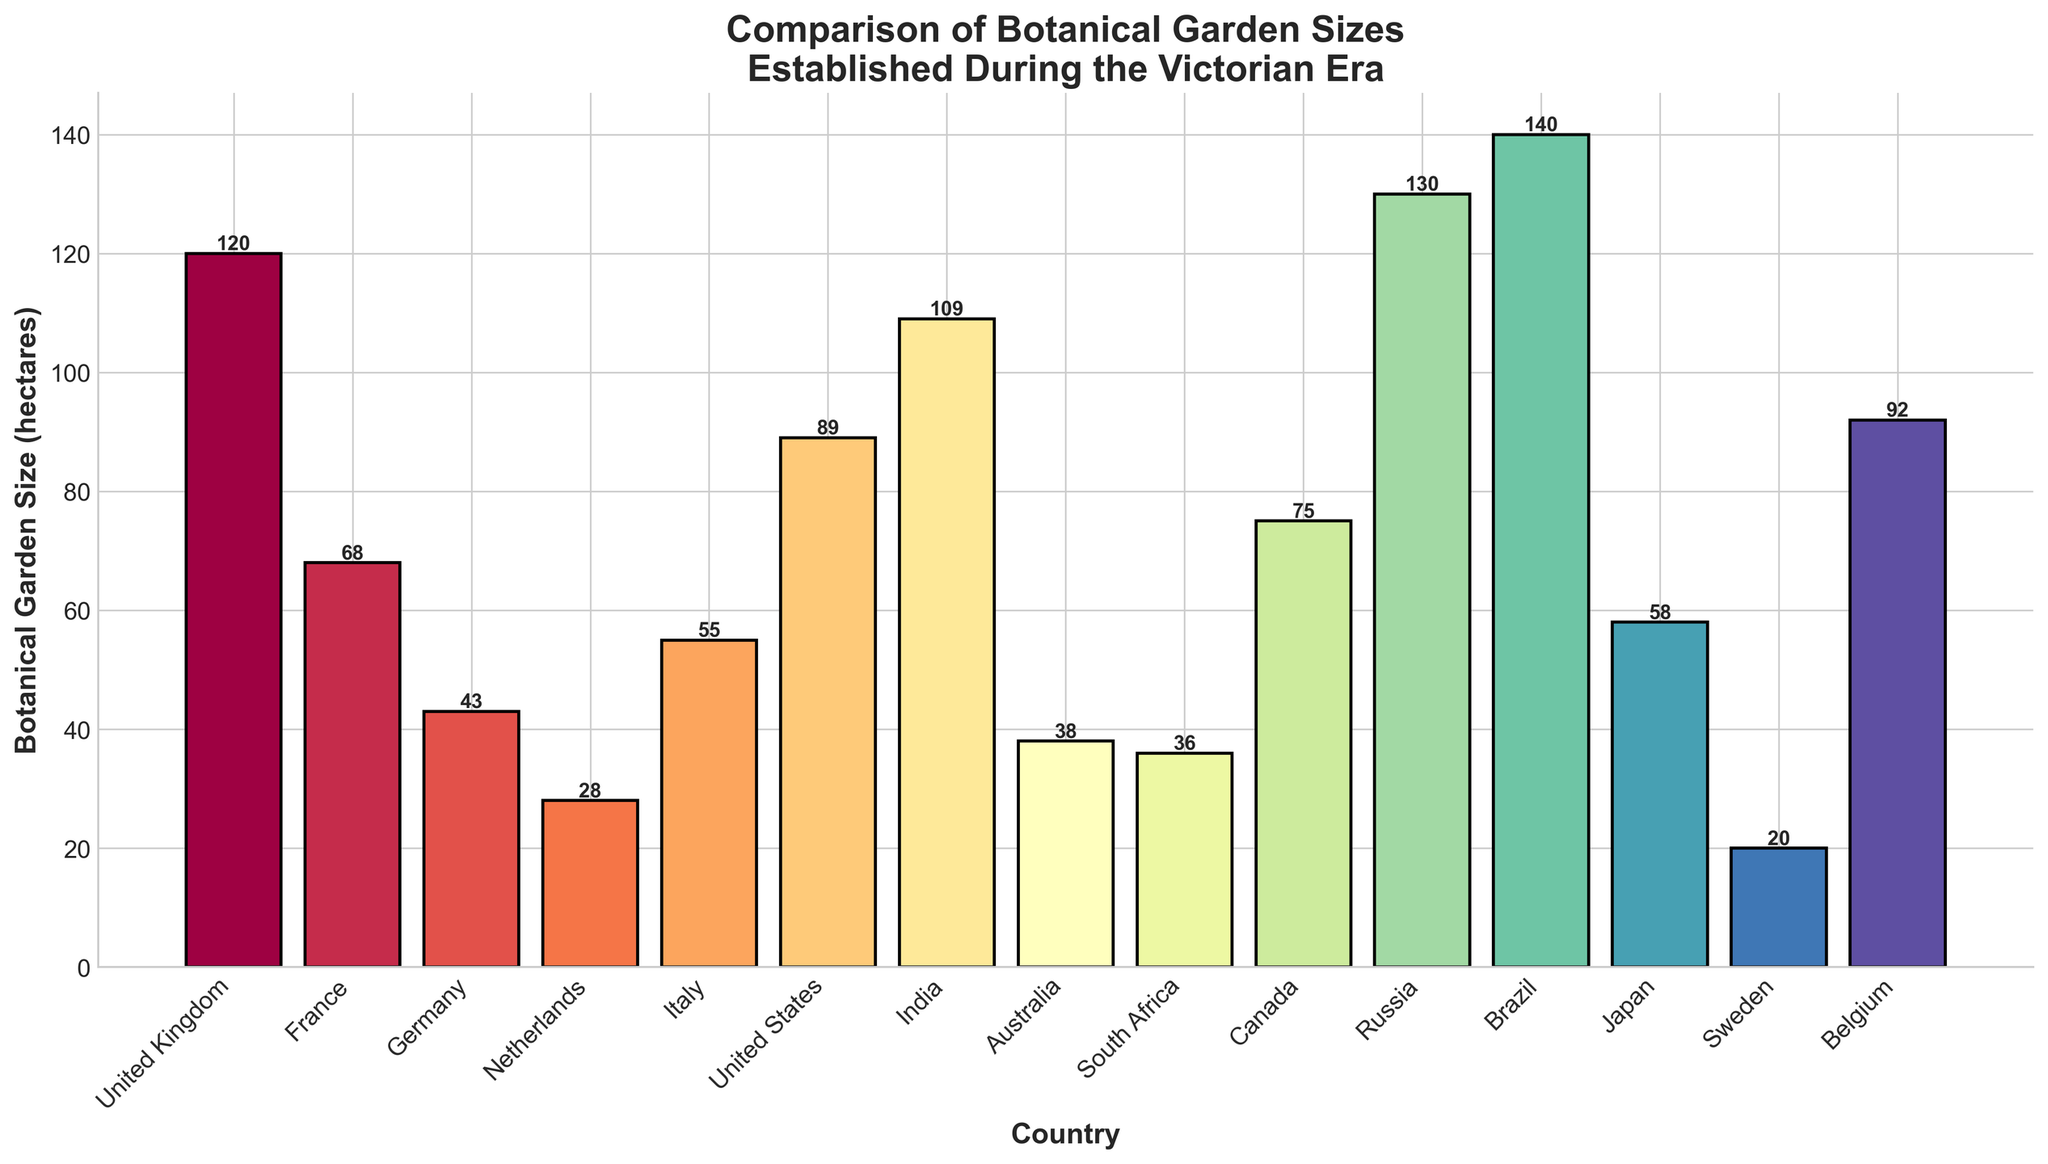Which country has the largest botanical garden established during the Victorian era? By examining the height of the bars, the tallest bar represents Brazil with 140 hectares.
Answer: Brazil What’s the total size of botanical gardens in the United Kingdom, United States, and Canada combined? Summing the sizes of the botanical gardens in the United Kingdom (120 hectares), United States (89 hectares), and Canada (75 hectares), we get 120 + 89 + 75 = 284 hectares.
Answer: 284 hectares Which countries have botanical gardens smaller than 50 hectares? The bars corresponding to Germany (43 hectares), Netherlands (28 hectares), Australia (38 hectares), and South Africa (36 hectares) are all below 50 hectares.
Answer: Germany, Netherlands, Australia, South Africa How much larger is the botanical garden in France compared to Italy? The bar for France shows 68 hectares, and for Italy, it's 55 hectares. Subtracting these gives 68 - 55 = 13 hectares.
Answer: 13 hectares Which countries have botanical gardens between 50 and 100 hectares? By observing the bars within this range, the countries are France (68 hectares), Italy (55 hectares), Japan (58 hectares), and Belgium (92 hectares).
Answer: France, Italy, Japan, Belgium How does the size of the botanical garden in Russia compare to that in Brazil? The bar for Brazil is slightly taller than that for Russia, with Brazil at 140 hectares and Russia at 130 hectares, making Brazil 10 hectares larger.
Answer: Brazil is larger by 10 hectares Are there more countries with botanical gardens larger than 70 hectares or smaller than 70 hectares? Counting the bars, there are 7 countries with gardens larger than 70 hectares (UK, US, Canada, India, Russia, Brazil, Belgium), and 8 countries with gardens smaller than 70 hectares (France, Germany, Netherlands, Italy, Australia, South Africa, Japan, Sweden). So, there are more countries with gardens smaller than 70 hectares.
Answer: Smaller than 70 hectares What’s the average size of the botanical gardens in the listed countries? Adding sizes: 120 + 68 + 43 + 28 + 55 + 89 + 109 + 38 + 36 + 75 + 130 + 140 + 58 + 20 + 92 = 1101 hectares. Dividing by the number of countries (15), the average is 1101 / 15 ≈ 73.4 hectares.
Answer: 73.4 hectares Which country in the southern hemisphere has the largest botanical garden? From the list, countries in the southern hemisphere include Australia (38 hectares), South Africa (36 hectares), and Brazil (140 hectares). Brazil has the largest botanical garden.
Answer: Brazil 